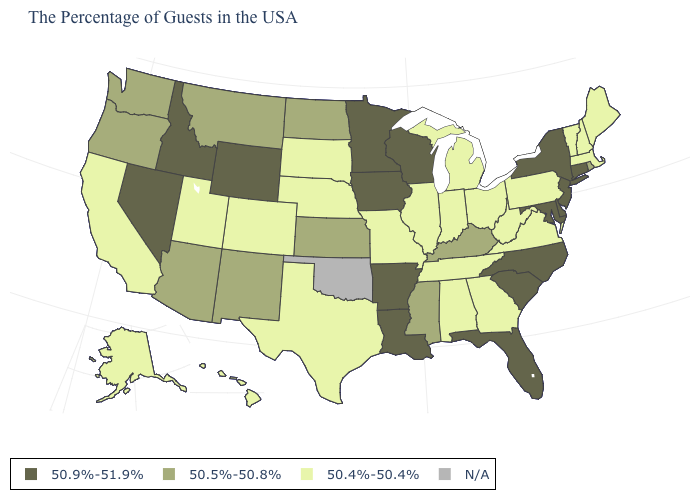What is the lowest value in states that border Pennsylvania?
Answer briefly. 50.4%-50.4%. Name the states that have a value in the range 50.5%-50.8%?
Keep it brief. Rhode Island, Kentucky, Mississippi, Kansas, North Dakota, New Mexico, Montana, Arizona, Washington, Oregon. What is the value of Delaware?
Give a very brief answer. 50.9%-51.9%. Does the map have missing data?
Give a very brief answer. Yes. Which states have the lowest value in the USA?
Short answer required. Maine, Massachusetts, New Hampshire, Vermont, Pennsylvania, Virginia, West Virginia, Ohio, Georgia, Michigan, Indiana, Alabama, Tennessee, Illinois, Missouri, Nebraska, Texas, South Dakota, Colorado, Utah, California, Alaska, Hawaii. Which states have the highest value in the USA?
Quick response, please. Connecticut, New York, New Jersey, Delaware, Maryland, North Carolina, South Carolina, Florida, Wisconsin, Louisiana, Arkansas, Minnesota, Iowa, Wyoming, Idaho, Nevada. Does West Virginia have the lowest value in the South?
Keep it brief. Yes. What is the value of New Jersey?
Keep it brief. 50.9%-51.9%. Name the states that have a value in the range 50.9%-51.9%?
Quick response, please. Connecticut, New York, New Jersey, Delaware, Maryland, North Carolina, South Carolina, Florida, Wisconsin, Louisiana, Arkansas, Minnesota, Iowa, Wyoming, Idaho, Nevada. Which states hav the highest value in the West?
Answer briefly. Wyoming, Idaho, Nevada. What is the highest value in the MidWest ?
Give a very brief answer. 50.9%-51.9%. What is the value of North Dakota?
Short answer required. 50.5%-50.8%. What is the highest value in the USA?
Keep it brief. 50.9%-51.9%. What is the lowest value in the Northeast?
Write a very short answer. 50.4%-50.4%. Which states have the lowest value in the USA?
Short answer required. Maine, Massachusetts, New Hampshire, Vermont, Pennsylvania, Virginia, West Virginia, Ohio, Georgia, Michigan, Indiana, Alabama, Tennessee, Illinois, Missouri, Nebraska, Texas, South Dakota, Colorado, Utah, California, Alaska, Hawaii. 